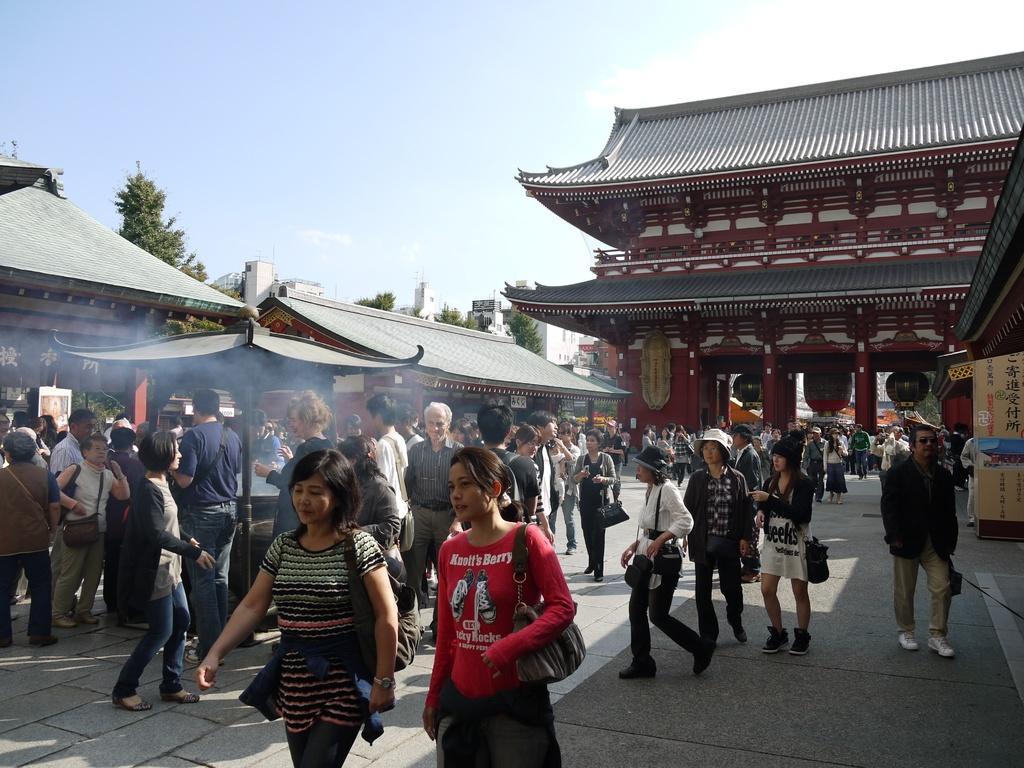Can you describe this image briefly? In this image we can see a group of people on the ground. We can also see some buildings with roof, poles, boards, some trees and the sky. 